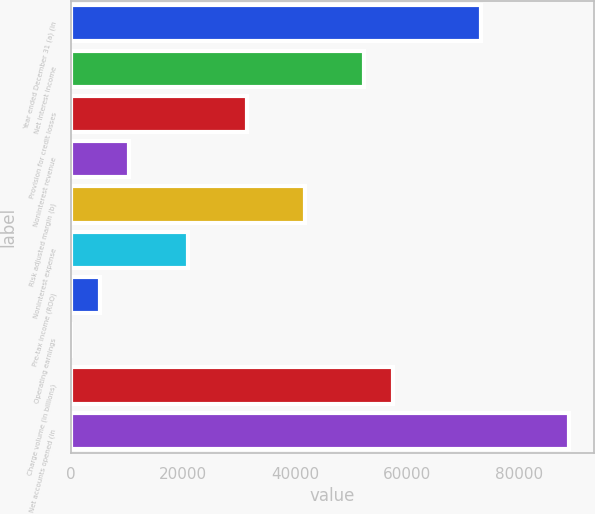<chart> <loc_0><loc_0><loc_500><loc_500><bar_chart><fcel>Year ended December 31 (a) (in<fcel>Net interest income<fcel>Provision for credit losses<fcel>Noninterest revenue<fcel>Risk adjusted margin (b)<fcel>Noninterest expense<fcel>Pre-tax income (ROO)<fcel>Operating earnings<fcel>Charge volume (in billions)<fcel>Net accounts opened (in<nl><fcel>73194.3<fcel>52282<fcel>31369.8<fcel>10457.5<fcel>41825.9<fcel>20913.6<fcel>5229.42<fcel>1.35<fcel>57510.1<fcel>88878.5<nl></chart> 